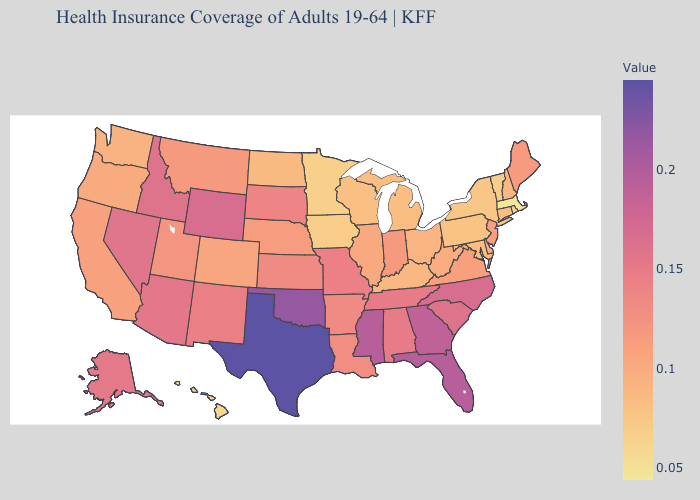Does West Virginia have a higher value than Tennessee?
Be succinct. No. Does Michigan have the lowest value in the MidWest?
Answer briefly. No. Does Maryland have the highest value in the South?
Answer briefly. No. Among the states that border Missouri , does Tennessee have the highest value?
Be succinct. No. Does Illinois have a lower value than South Carolina?
Write a very short answer. Yes. Does Wyoming have the highest value in the USA?
Give a very brief answer. No. 